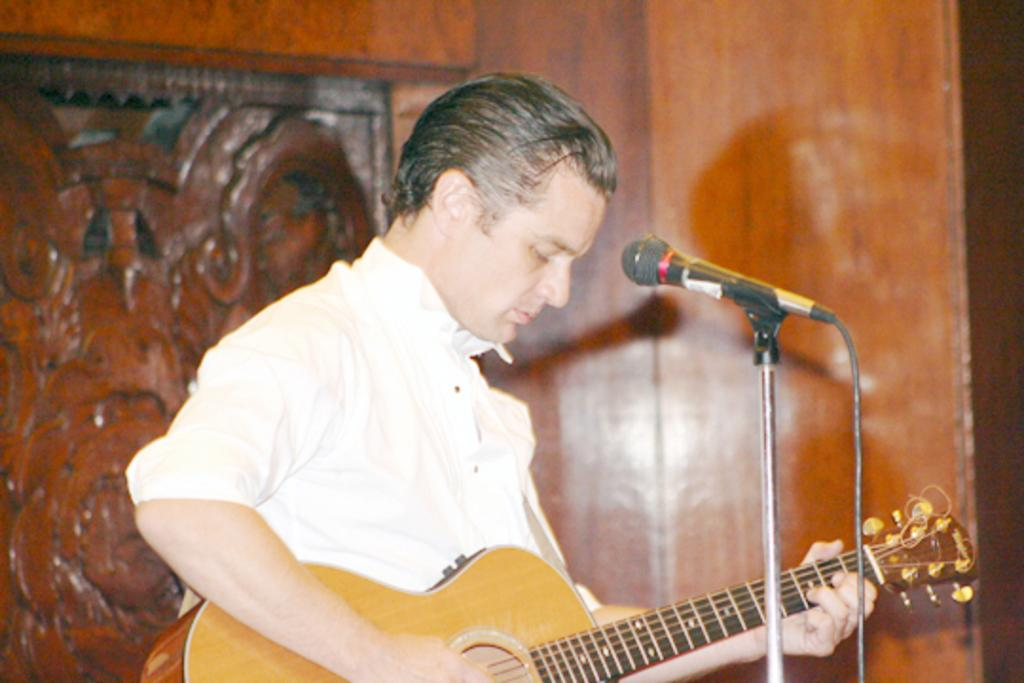Who is the main subject in the image? There is a man in the image. What is the man wearing? The man is wearing a white shirt. What is the man doing in the image? The man is playing a guitar. What object is in front of the man? There is a microphone in front of the man. What can be seen in the background of the image? There is a wooden wall in the background of the image. How many sticks are the man using to play the guitar in the image? The man is not using any sticks to play the guitar in the image; he is using his hands. What is the name of the man's son in the image? There is no son present in the image, and therefore no name can be given. 